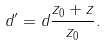Convert formula to latex. <formula><loc_0><loc_0><loc_500><loc_500>d ^ { \prime } = d \frac { z _ { 0 } + z } { z _ { 0 } } .</formula> 